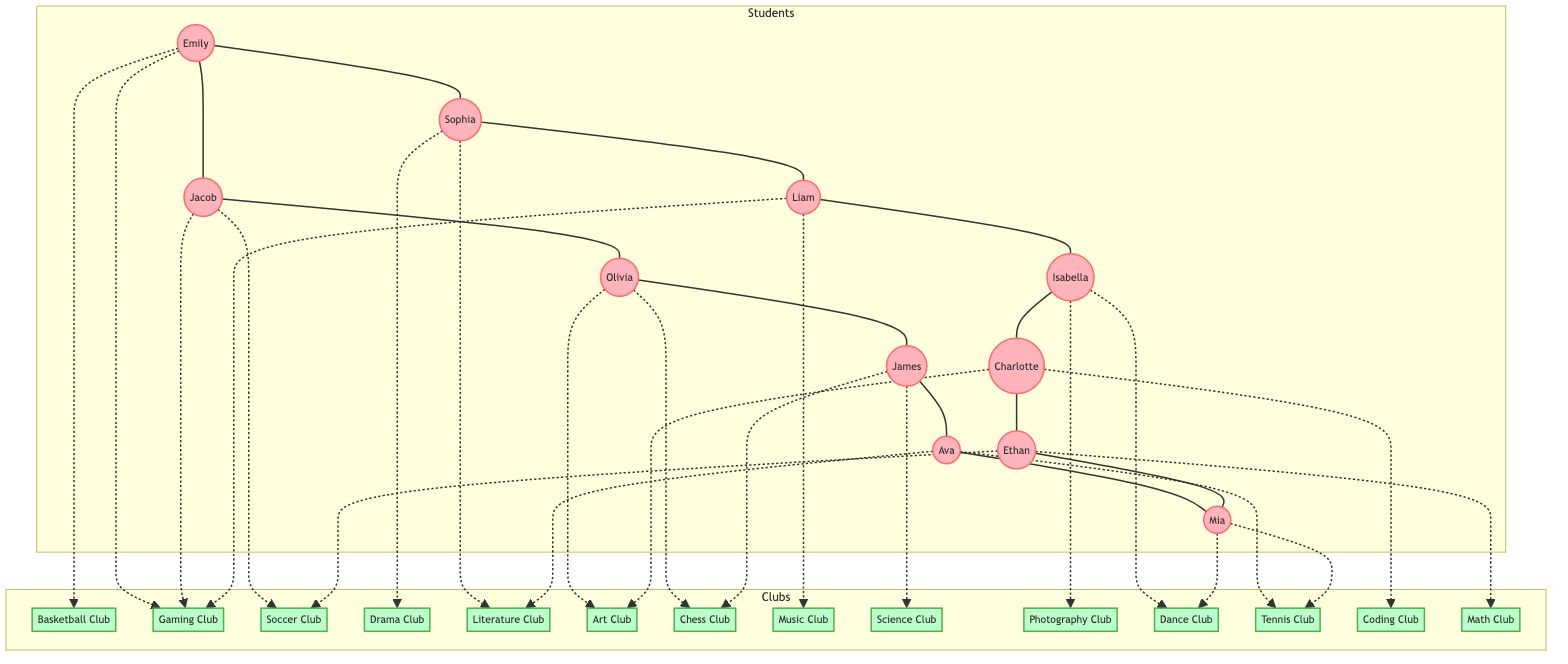What are the names of the students in grade 10? By looking at the "Students" subgraph, I can identify students who are in grade 10. They are Emily, Jacob, Charlotte, and Ethan.
Answer: Emily, Jacob, Charlotte, Ethan Which club does Jacob belong to? In the "Clubs" subgraph, I can find Jacob's name under two clubs, the "Gaming Club" and "Soccer Club."
Answer: Gaming Club, Soccer Club How many students are members of the Music Club? The "Music Club" node shows that Liam is the only member. Counting this gives me one member in total.
Answer: 1 Who are friends with Sophia? Looking at the connections from Sophia in the diagram, I see she is friends with Emily and Liam.
Answer: Emily, Liam Which club has the most members? Analyzing the membership counts of each club, I find the "Gaming Club" has three members (Emily, Jacob, and Liam) while the others have fewer, making it the largest.
Answer: Gaming Club Does Emily have a friend in the Drama Club? Checking the friends of Emily, which are Jacob and Sophia, and knowing Sophia is the only member of the Drama Club, I can see that she does indeed have a friend in that club.
Answer: Yes Which grade is Liam in? In the "Students" subgraph, Liam is indicated to be in grade 12.
Answer: 12 How are Olivia and James connected? I can see from the diagram that Olivia and James are directly connected as friends.
Answer: Friends Is there any student who is a member of both the Chess Club and the Art Club? By looking at the club memberships, I find Olivia is in both the Chess Club and the Art Club.
Answer: Yes 